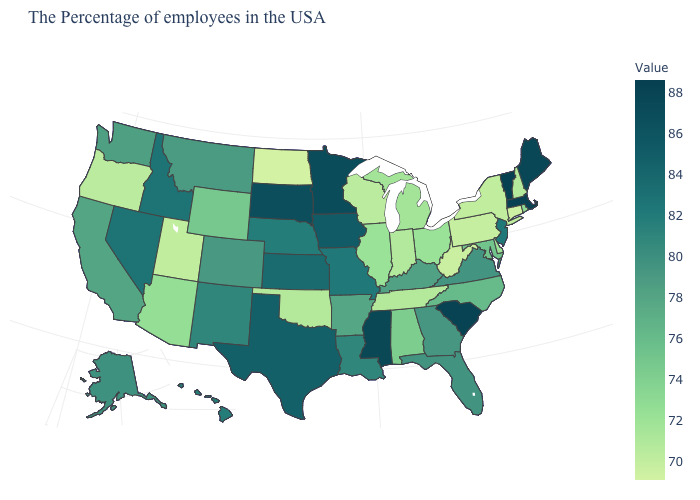Does Alabama have the highest value in the USA?
Write a very short answer. No. Among the states that border Texas , which have the highest value?
Concise answer only. Louisiana, New Mexico. Does the map have missing data?
Concise answer only. No. Does Connecticut have the lowest value in the Northeast?
Keep it brief. Yes. Does Mississippi have the highest value in the South?
Write a very short answer. No. Which states have the highest value in the USA?
Write a very short answer. Vermont. 